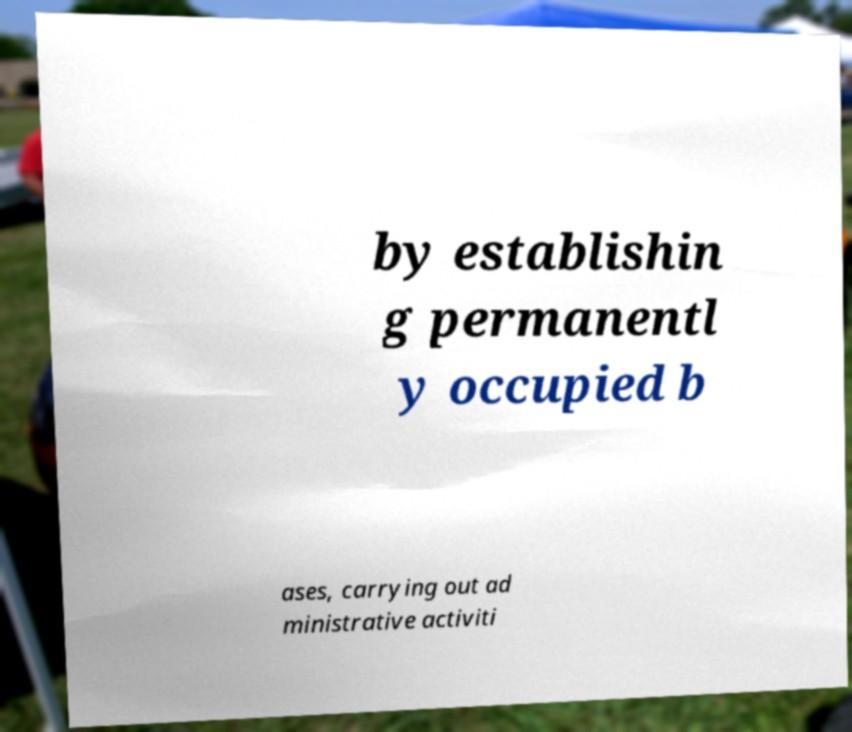Can you accurately transcribe the text from the provided image for me? by establishin g permanentl y occupied b ases, carrying out ad ministrative activiti 